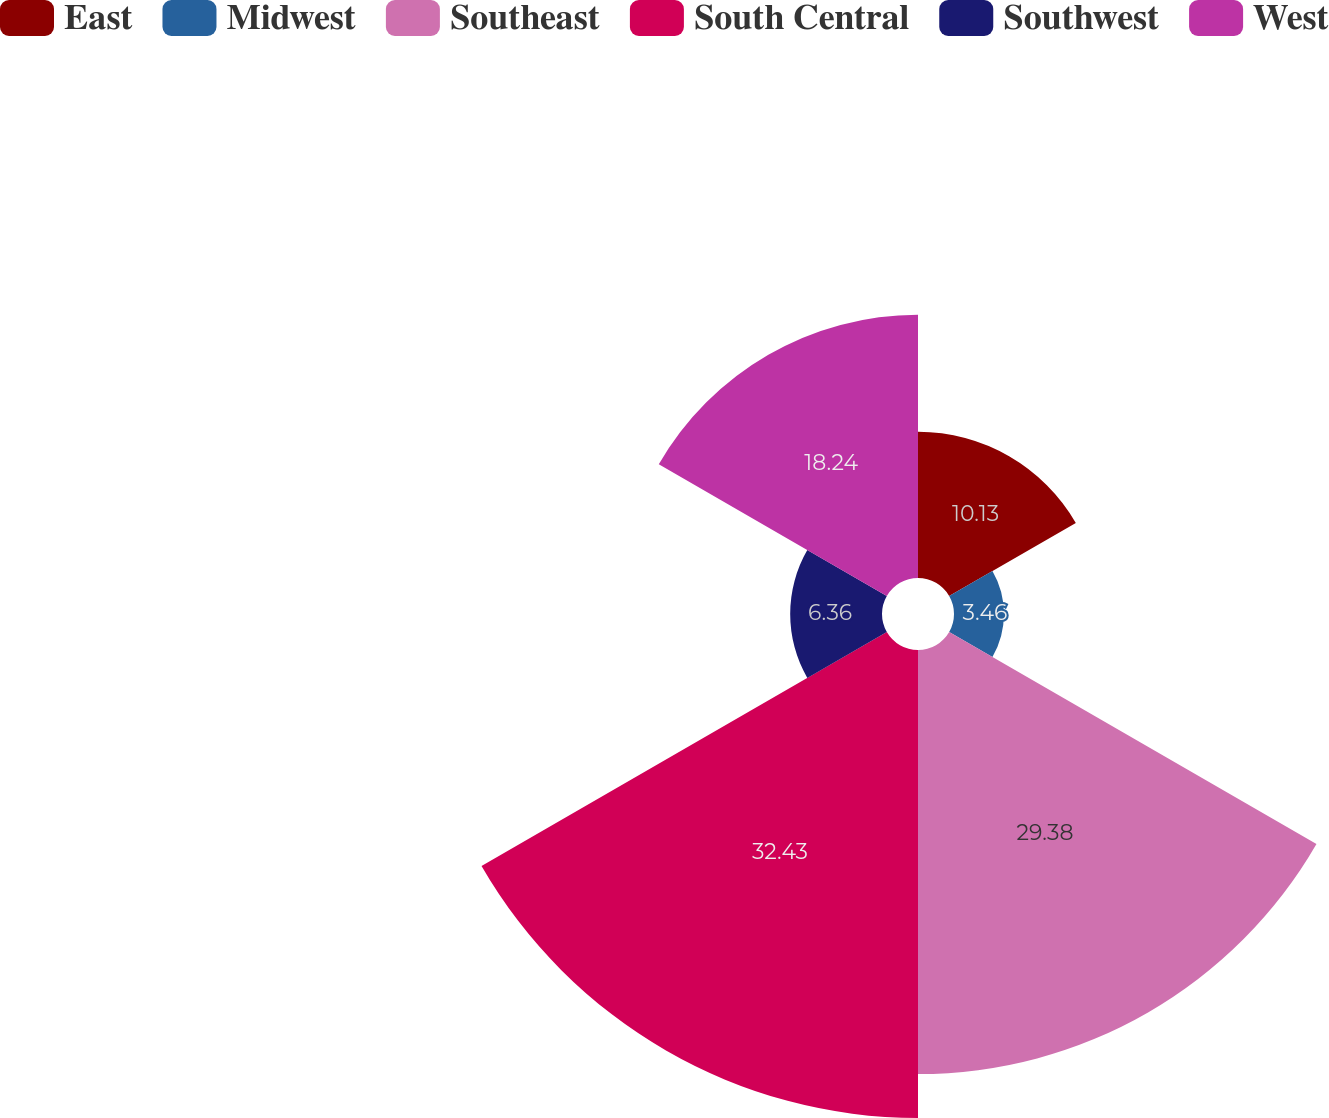<chart> <loc_0><loc_0><loc_500><loc_500><pie_chart><fcel>East<fcel>Midwest<fcel>Southeast<fcel>South Central<fcel>Southwest<fcel>West<nl><fcel>10.13%<fcel>3.46%<fcel>29.38%<fcel>32.42%<fcel>6.36%<fcel>18.24%<nl></chart> 